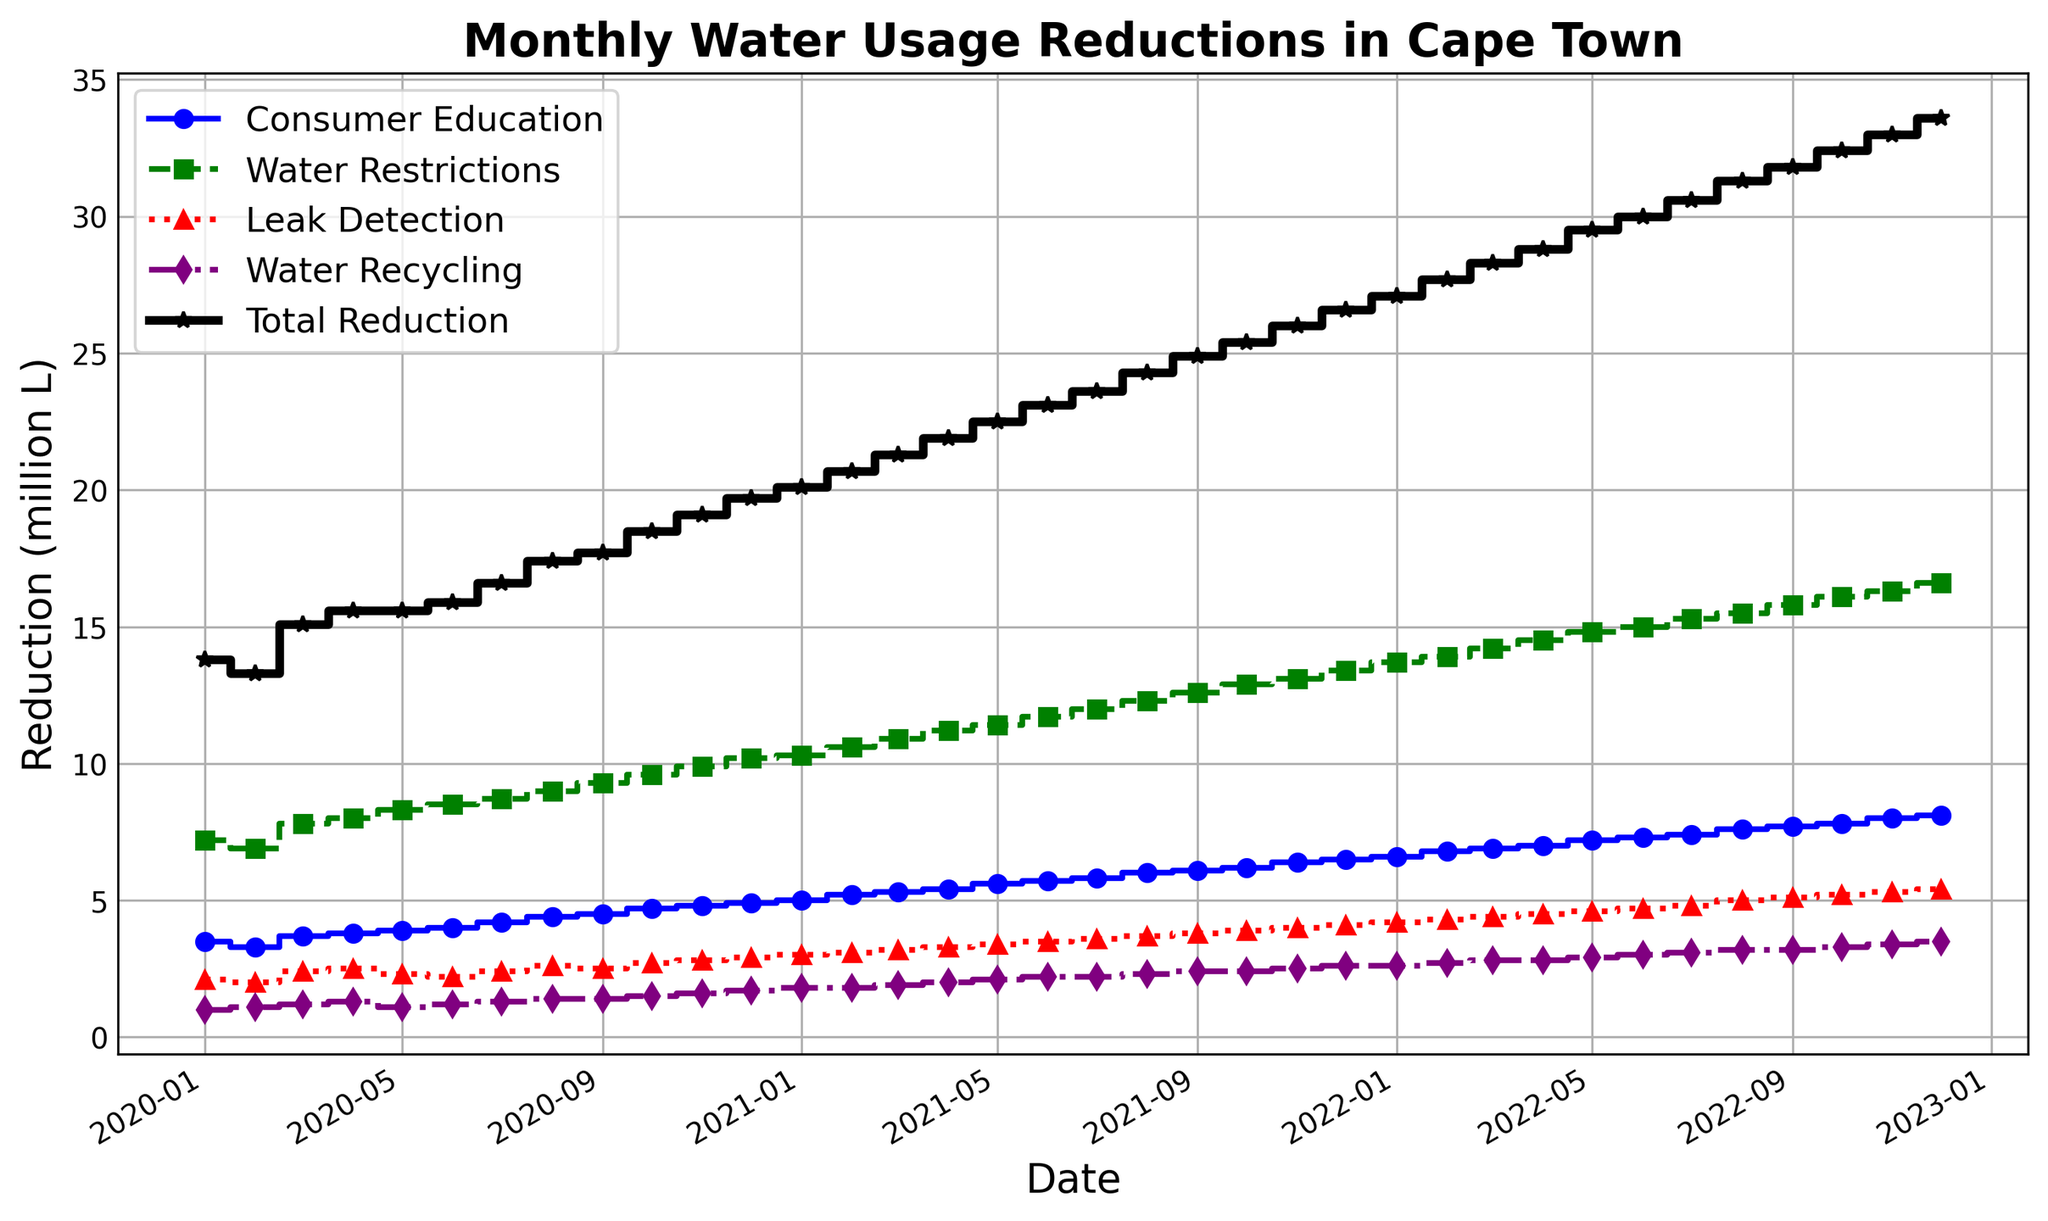How much water savings were achieved through Consumer Education and Water Recycling combined in April 2020? The figure shows individual reductions for each measure. In April 2020, Consumer Education achieved 3.8 million liters, and Water Recycling achieved 1.3 million liters. Adding these together gives 3.8 + 1.3 = 5.1 million liters.
Answer: 5.1 million liters Which measure contributed the most to water savings in December 2022? By looking at the figure, the highest step value for December 2022 is for Water Restrictions.
Answer: Water Restrictions Between January 2020 and December 2022, which conservation method shows the steepest increase in savings? By comparing the slopes of the lines, Water Restrictions demonstrates the steepest increase from approximately 7.2 million liters to 16.6 million liters.
Answer: Water Restrictions What's the difference in water reduction achieved through Leak Detection between January 2021 and January 2022? In January 2021, Leak Detection achieved 3.0 million liters, whereas, in January 2022, it achieved 4.2 million liters. The difference is 4.2 - 3.0 = 1.2 million liters.
Answer: 1.2 million liters How does the total water reduction in July 2021 compare to that in July 2022? In July 2021, the total reduction was 23.6 million liters, and in July 2022, it was 30.6 million liters. Comparing them shows an increase: 30.6 - 23.6 = 7.0 million liters.
Answer: 30.6 > 23.6 by 7.0 million liters Which conservation measure consistently increased month-by-month without any decrease over the entire period? By visually inspecting the line plots, Consumer Education consistently increases without any dips from January 2020 to December 2022.
Answer: Consumer Education What's the average monthly reduction achieved by Water Recycling in 2021? Summing up the reduction values for Water Recycling in 2021 (1.8 + 1.8 + 1.9 + 2.0 + 2.1 + 2.2 + 2.2 + 2.3 + 2.4 + 2.4 + 2.5 + 2.6) gives 26.2 million liters. Dividing by 12 months, the average is 26.2/12 = ~2.18 million liters.
Answer: ~2.18 million liters In December 2021, what is the combined total reduction achieved through Water Restrictions and Water Recycling? In December 2021, Water Restrictions achieved 13.4 million liters, and Water Recycling achieved 2.6 million liters. The combined total is 13.4 + 2.6 = 16 million liters.
Answer: 16 million liters Which step line shows a dotted pattern, and what water conservation method does it represent? The figure uses a purple dotted line to represent Water Recycling.
Answer: Water Recycling How much did the total water reduction increase between December 2020 and December 2022? In December 2020, the total reduction was 19.7 million liters, and in December 2022, it was 33.6 million liters. The increase is 33.6 - 19.7 = 13.9 million liters.
Answer: 13.9 million liters 